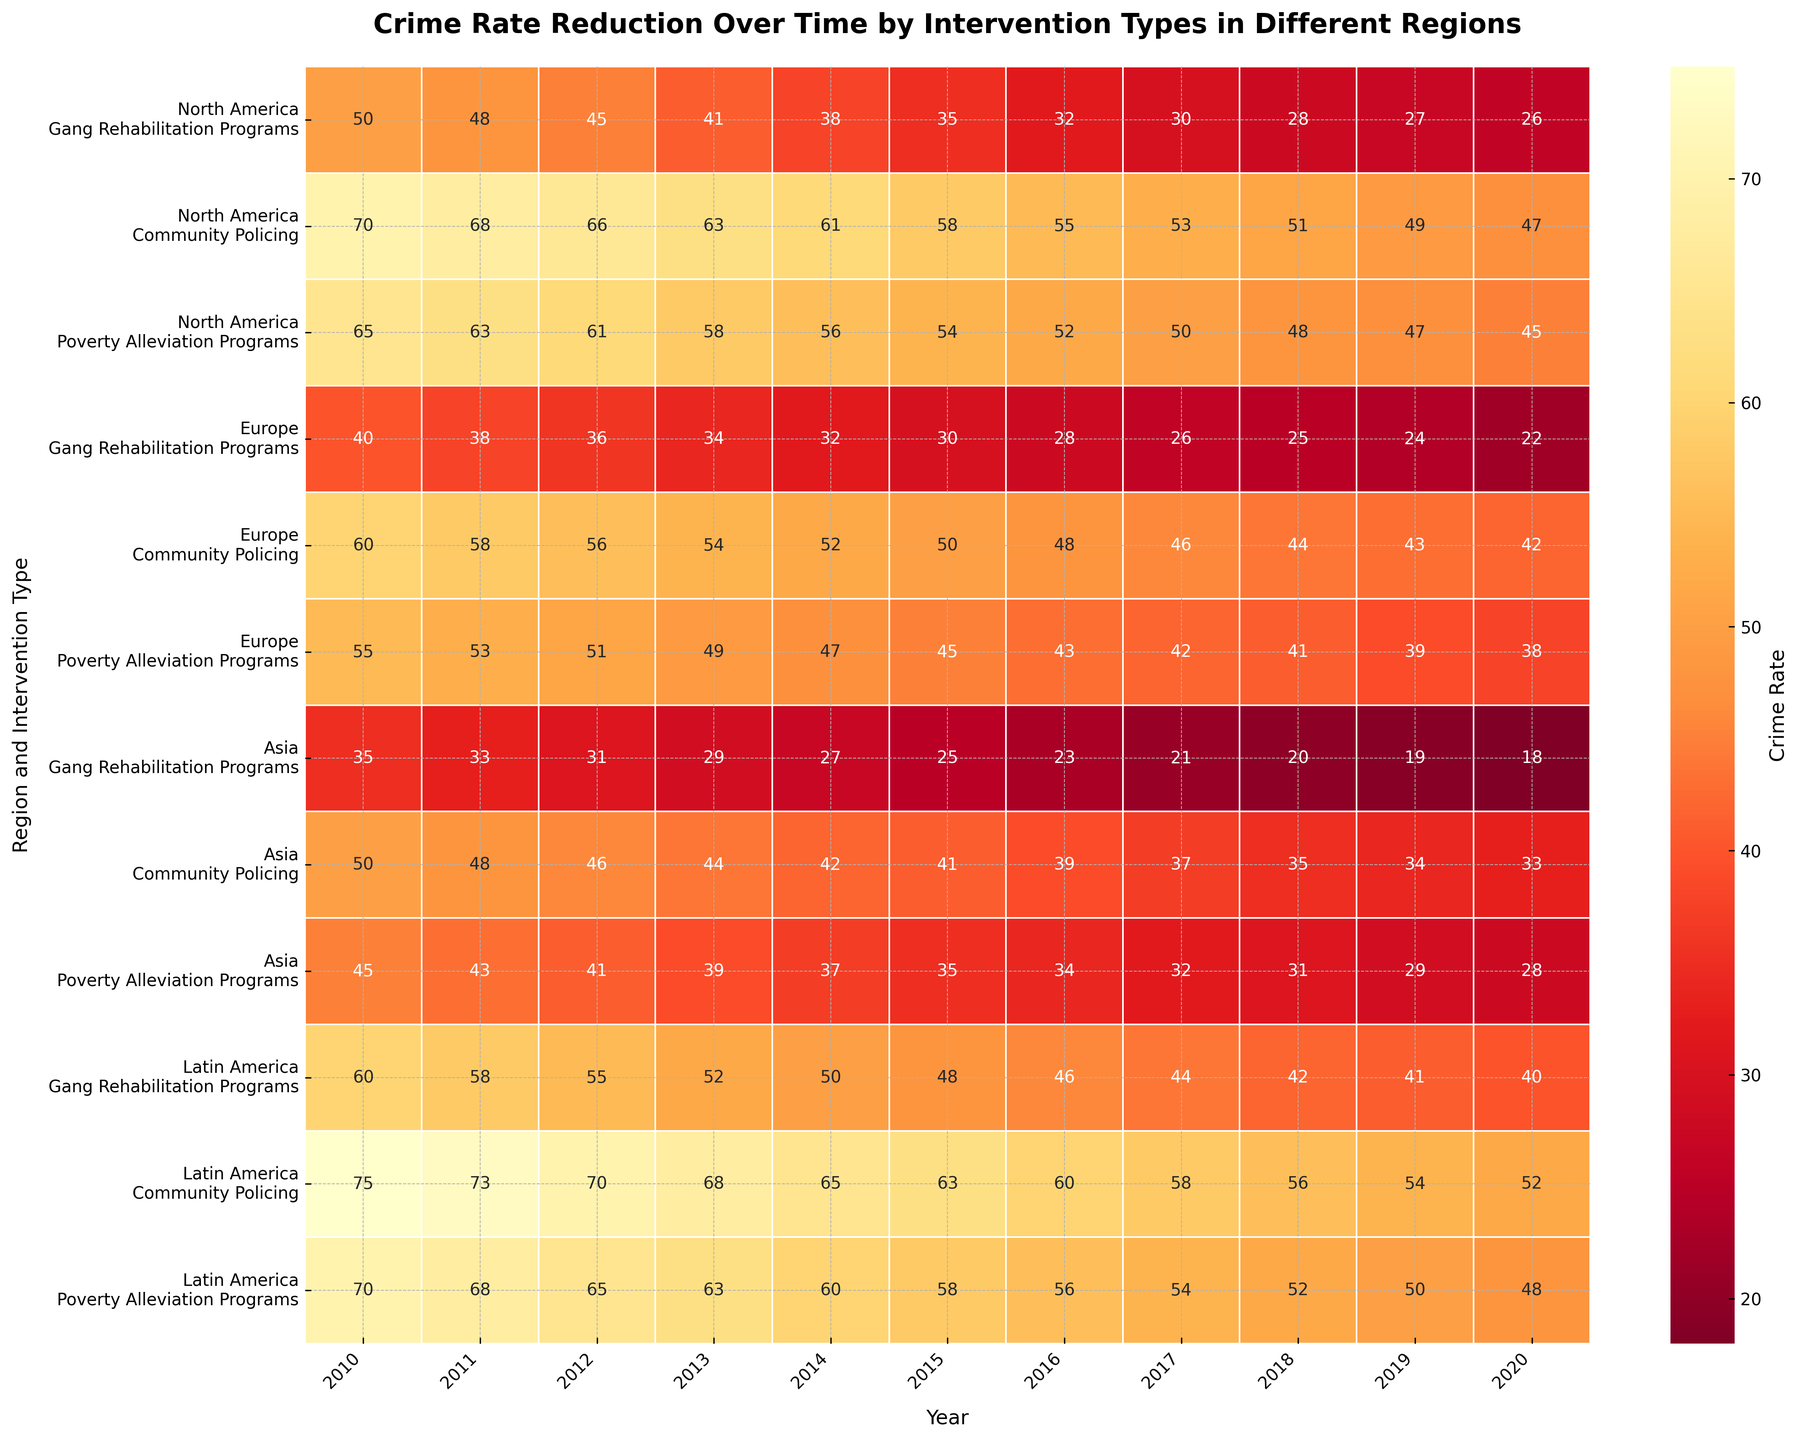What is the general trend of crime rates over time across all interventions and regions? The heatmap shows a consistent reduction in crime rates for all the intervention types across different regions from 2010 to 2020, with crime rates decreasing year by year. This decline is illustrated by the colors gradually moving from darker (higher crime rates) to lighter shades (lower crime rates).
Answer: Crime rates are generally decreasing Which region had the lowest crime rate for Gang Rehabilitation Programs in 2020? The lowest value for Gang Rehabilitation Programs in 2020 can be seen for Europe, as the crime rate is marked as 22. The visual features make this evident against the lighter background color.
Answer: Europe How does the effectiveness of Poverty Alleviation Programs in reducing crime rates compare between North America and Latin America in 2020? In 2020, North America shows a crime rate of 45 for Poverty Alleviation Programs, whereas Latin America shows a rate of 48. Comparing these values shows that North America had a slightly lower crime rate.
Answer: North America Which intervention type shows the highest effectiveness in Latin America over the 10 years covered? By examining the progressively lighter colors over the years, Community Policing in Latin America shows the most significant drop, reducing from 75 in 2010 to 52 in 2020. This larger decrease indicates higher effectiveness.
Answer: Community Policing What's the median crime rate for Europe in 2015 across all intervention types? The crime rates for the three intervention types in Europe in 2015 are 30, 50, and 45. Sorting these values gives 30, 45, 50. Hence, the median value (middle value) is 45.
Answer: 45 Which intervention type shows the steepest reduction in crime rates in Asia from 2010 to 2020? For Asia, Gang Rehabilitation Programs reduce from 35 to 18. Calculating the change (35 - 18 = 17), this intervention type shows the steepest decrease in crime rates.
Answer: Gang Rehabilitation Programs By 2020, have crime rates in North America for Community Policing fallen below the crime rate for Poverty Alleviation Programs in Asia? In 2020, Community Policing in North America has a crime rate of 47, while Poverty Alleviation Programs in Asia have a rate of 28. Since 47 > 28, Community Policing in North America has not fallen below the rate for Poverty Alleviation Programs in Asia.
Answer: No How do the crime rates for Community Policing compare across all regions in 2019? For 2019, the crime rates for Community Policing are North America (49), Europe (43), Asia (34), and Latin America (54). Comparing these values, Asia has the lowest rates, followed by Europe, North America, and then Latin America.
Answer: Asia In which year did Europe achieve an overall crime rate below 50 for Community Policing? Examining Europe for Community Policing over the years, the overall crime rate falls below 50 starting from 2016, signified by the number 48 for 2016.
Answer: 2016 What is the difference in crime rates between the highest and lowest interventions in North America for 2012? In North America for 2012, the crime rates are 45 for Gang Rehabilitation, 66 for Community Policing, and 61 for Poverty Alleviation. The difference between the highest (66) and lowest (45) is 66 - 45 = 21.
Answer: 21 